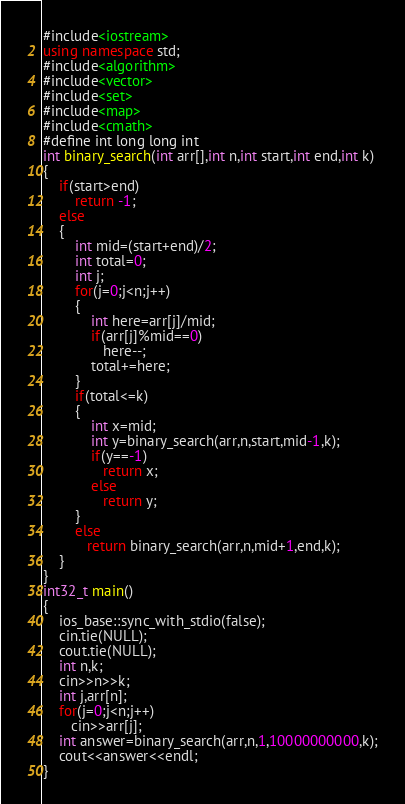Convert code to text. <code><loc_0><loc_0><loc_500><loc_500><_C++_>#include<iostream>
using namespace std;
#include<algorithm>
#include<vector>
#include<set>
#include<map>
#include<cmath>
#define int long long int
int binary_search(int arr[],int n,int start,int end,int k)
{
	if(start>end)
	    return -1;
	else
	{
		int mid=(start+end)/2;
		int total=0;
		int j;
		for(j=0;j<n;j++)
		{
			int here=arr[j]/mid;
			if(arr[j]%mid==0)
			   here--;
			total+=here;
		}
		if(total<=k)
		{
			int x=mid;
			int y=binary_search(arr,n,start,mid-1,k);
			if(y==-1)
			   return x;
			else
			   return y;
		}
		else
		   return binary_search(arr,n,mid+1,end,k);
	}
}
int32_t main()
{
	ios_base::sync_with_stdio(false);
	cin.tie(NULL);
	cout.tie(NULL);
	int n,k;
	cin>>n>>k;
	int j,arr[n];
	for(j=0;j<n;j++)
	   cin>>arr[j];
	int answer=binary_search(arr,n,1,10000000000,k);
	cout<<answer<<endl;
}
</code> 